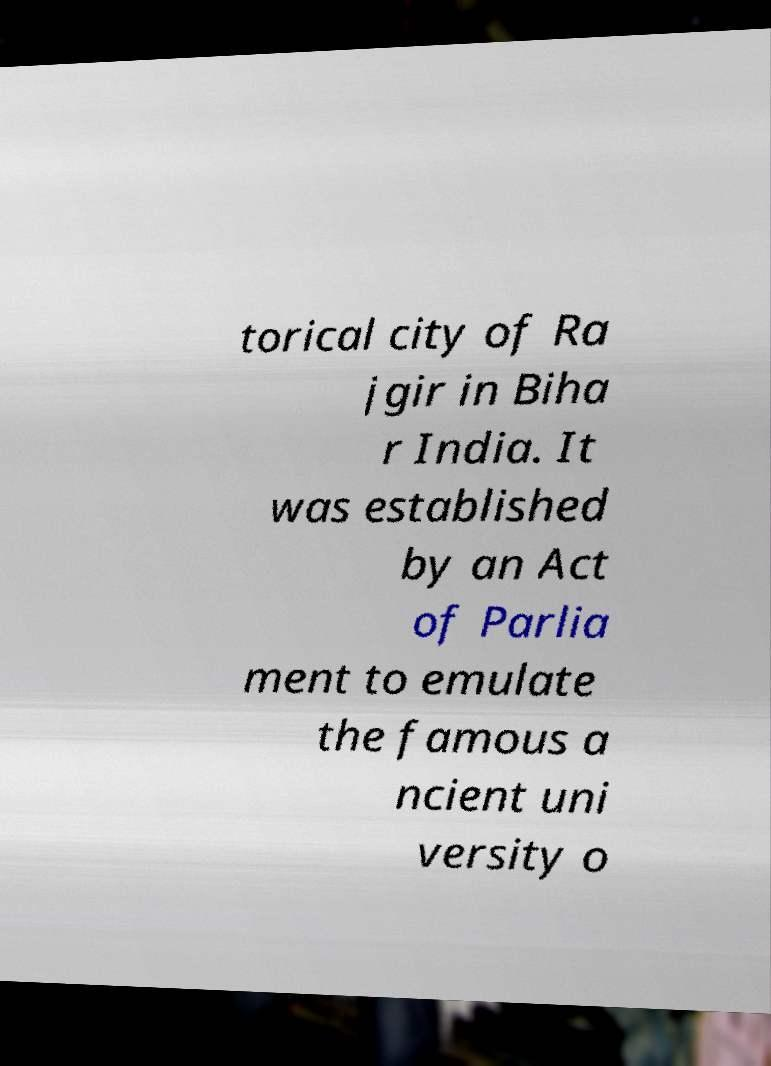Please read and relay the text visible in this image. What does it say? torical city of Ra jgir in Biha r India. It was established by an Act of Parlia ment to emulate the famous a ncient uni versity o 